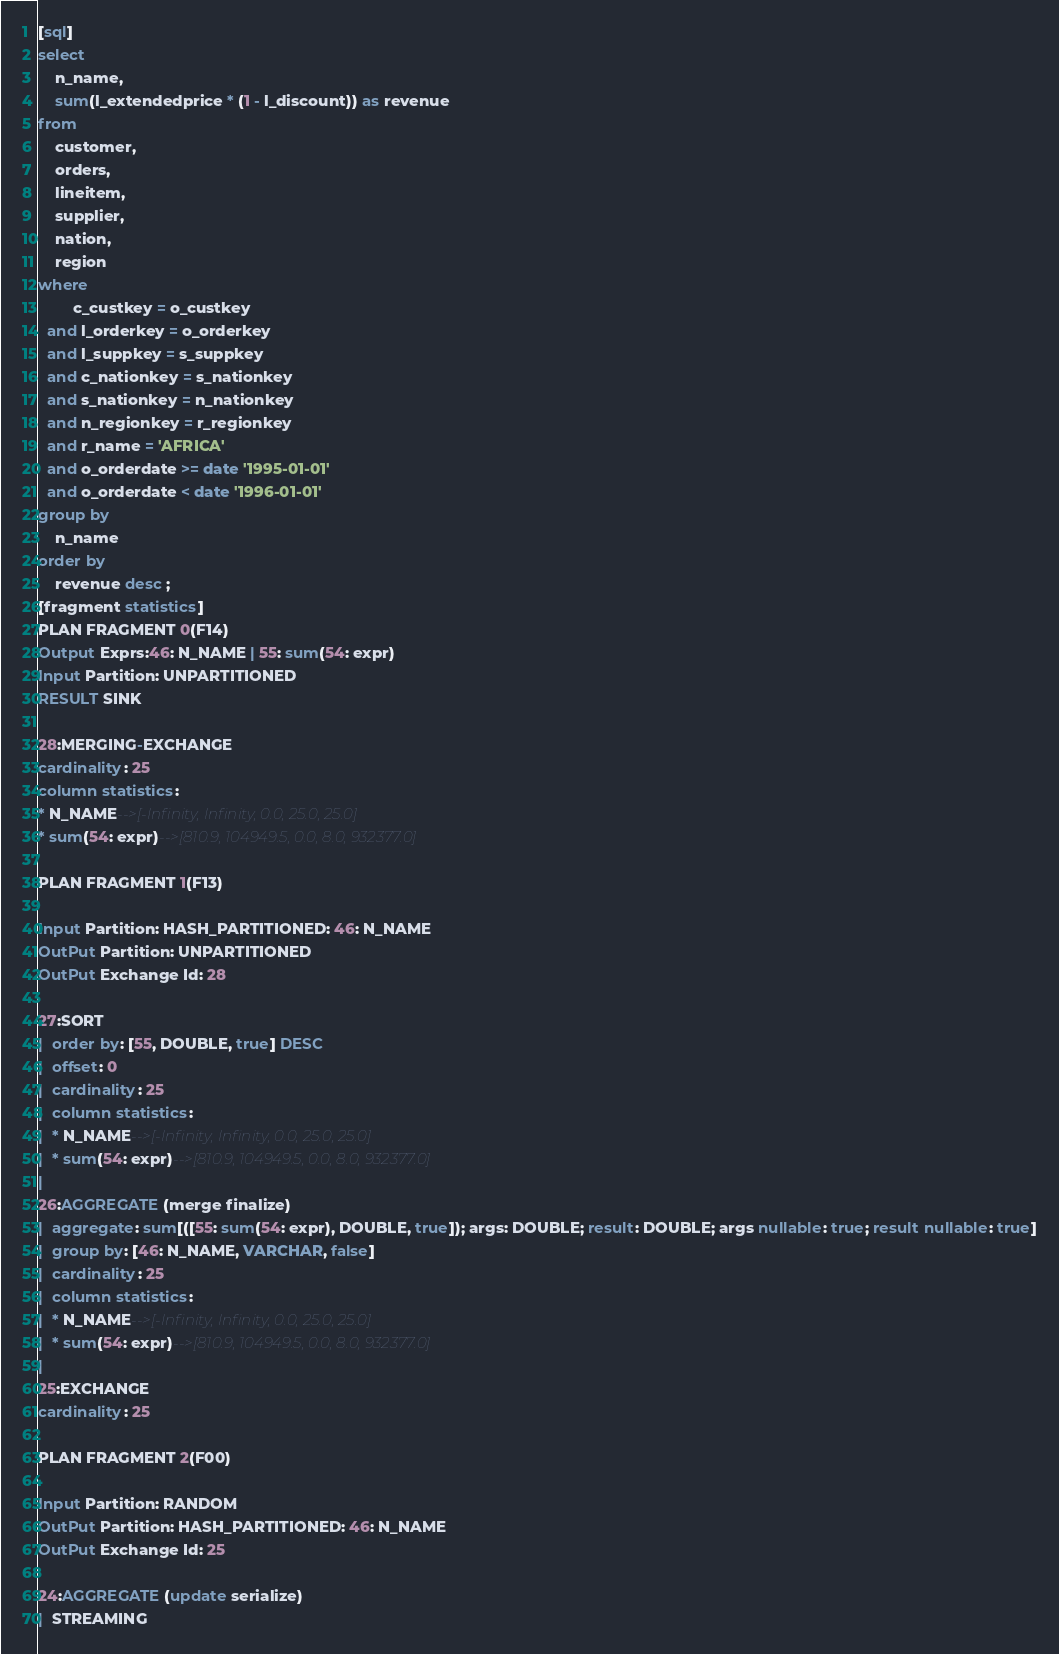<code> <loc_0><loc_0><loc_500><loc_500><_SQL_>[sql]
select
    n_name,
    sum(l_extendedprice * (1 - l_discount)) as revenue
from
    customer,
    orders,
    lineitem,
    supplier,
    nation,
    region
where
        c_custkey = o_custkey
  and l_orderkey = o_orderkey
  and l_suppkey = s_suppkey
  and c_nationkey = s_nationkey
  and s_nationkey = n_nationkey
  and n_regionkey = r_regionkey
  and r_name = 'AFRICA'
  and o_orderdate >= date '1995-01-01'
  and o_orderdate < date '1996-01-01'
group by
    n_name
order by
    revenue desc ;
[fragment statistics]
PLAN FRAGMENT 0(F14)
Output Exprs:46: N_NAME | 55: sum(54: expr)
Input Partition: UNPARTITIONED
RESULT SINK

28:MERGING-EXCHANGE
cardinality: 25
column statistics:
* N_NAME-->[-Infinity, Infinity, 0.0, 25.0, 25.0]
* sum(54: expr)-->[810.9, 104949.5, 0.0, 8.0, 932377.0]

PLAN FRAGMENT 1(F13)

Input Partition: HASH_PARTITIONED: 46: N_NAME
OutPut Partition: UNPARTITIONED
OutPut Exchange Id: 28

27:SORT
|  order by: [55, DOUBLE, true] DESC
|  offset: 0
|  cardinality: 25
|  column statistics:
|  * N_NAME-->[-Infinity, Infinity, 0.0, 25.0, 25.0]
|  * sum(54: expr)-->[810.9, 104949.5, 0.0, 8.0, 932377.0]
|
26:AGGREGATE (merge finalize)
|  aggregate: sum[([55: sum(54: expr), DOUBLE, true]); args: DOUBLE; result: DOUBLE; args nullable: true; result nullable: true]
|  group by: [46: N_NAME, VARCHAR, false]
|  cardinality: 25
|  column statistics:
|  * N_NAME-->[-Infinity, Infinity, 0.0, 25.0, 25.0]
|  * sum(54: expr)-->[810.9, 104949.5, 0.0, 8.0, 932377.0]
|
25:EXCHANGE
cardinality: 25

PLAN FRAGMENT 2(F00)

Input Partition: RANDOM
OutPut Partition: HASH_PARTITIONED: 46: N_NAME
OutPut Exchange Id: 25

24:AGGREGATE (update serialize)
|  STREAMING</code> 